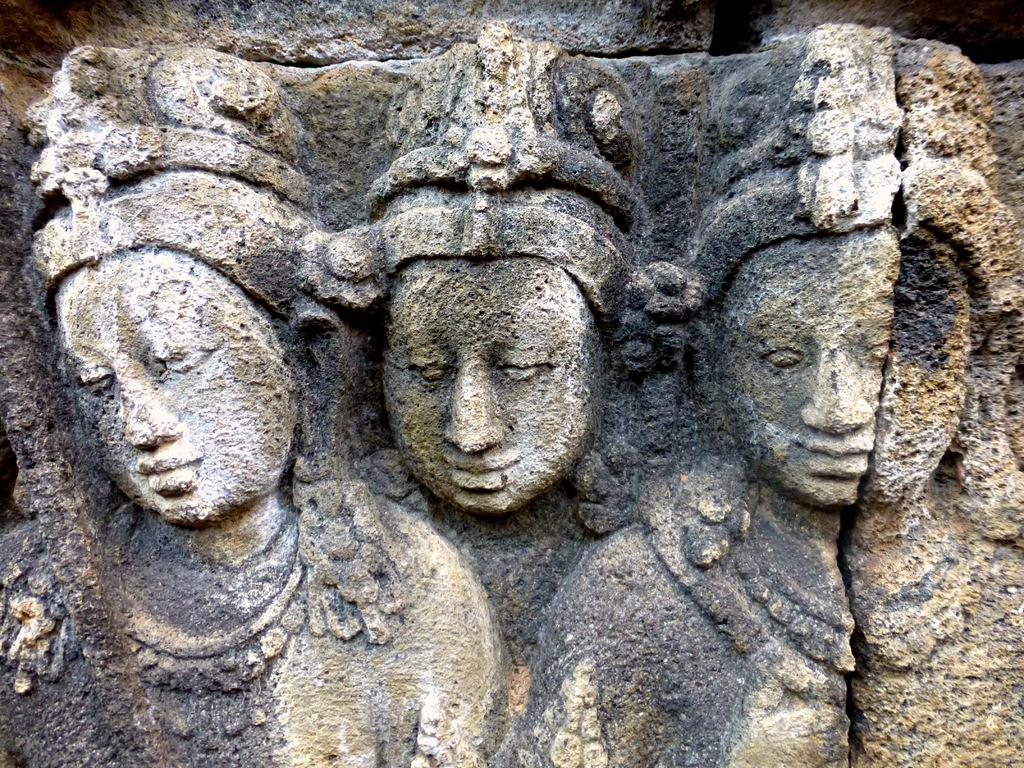What type of objects are present in the image? There are idols in the image. What material are the idols made of? The idols are carved on stone. What type of veil is draped over the idols in the image? There is no veil present in the image; the idols are carved on stone. What song can be heard playing in the background of the image? There is no sound or music present in the image, so it is not possible to determine what song might be heard. 